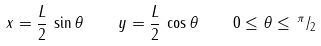<formula> <loc_0><loc_0><loc_500><loc_500>x = \frac { L } { 2 } \, \sin \theta \quad y = \frac { L } { 2 } \, \cos \theta \quad 0 \leq \theta \leq \, ^ { \pi } / _ { 2 }</formula> 